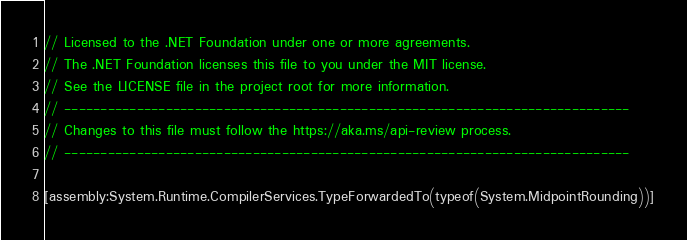<code> <loc_0><loc_0><loc_500><loc_500><_C#_>// Licensed to the .NET Foundation under one or more agreements.
// The .NET Foundation licenses this file to you under the MIT license.
// See the LICENSE file in the project root for more information.
// ------------------------------------------------------------------------------
// Changes to this file must follow the https://aka.ms/api-review process.
// ------------------------------------------------------------------------------

[assembly:System.Runtime.CompilerServices.TypeForwardedTo(typeof(System.MidpointRounding))]
</code> 